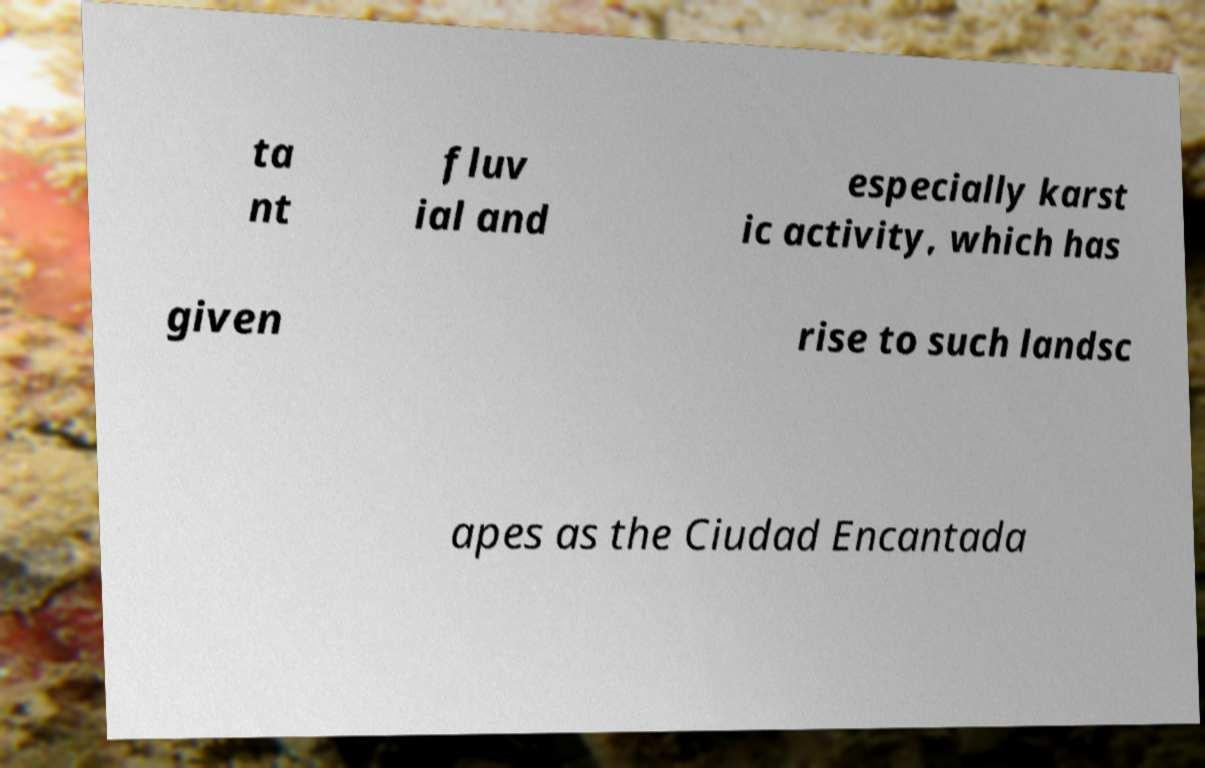Please read and relay the text visible in this image. What does it say? ta nt fluv ial and especially karst ic activity, which has given rise to such landsc apes as the Ciudad Encantada 